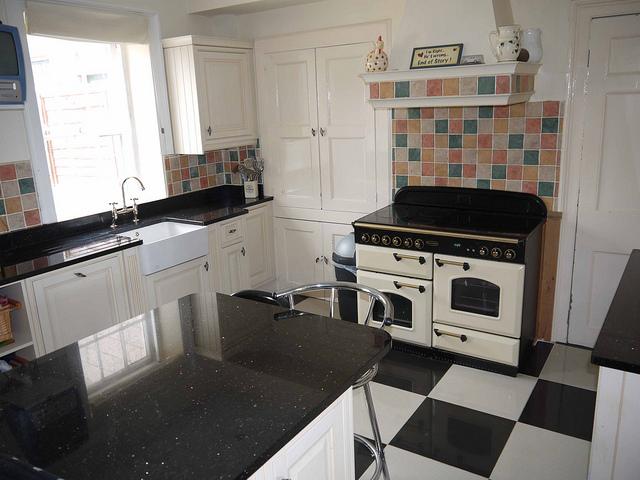Is there a roll of paper towels?
Quick response, please. No. Is there a trash can near the kitchen cabinet?
Concise answer only. Yes. How many electrical appliances are showing?
Give a very brief answer. 1. What color is the door?
Keep it brief. White. Is there a roll of paper towel next to the oven?
Be succinct. No. How many knobs are on the stove?
Short answer required. 9. Is there any carpet in the room?
Concise answer only. No. What kind of equipment is set up in front of the oven?
Keep it brief. Chair. How old is the countertop?
Be succinct. 1 year. Are there blinds on the window?
Quick response, please. No. What kind of room is this?
Quick response, please. Kitchen. Is it a gas stove?
Give a very brief answer. No. Is there a trash can next to the stove?
Short answer required. Yes. What is plugged up to the wall?
Give a very brief answer. Stove. Is there a way to make coffee?
Concise answer only. No. 